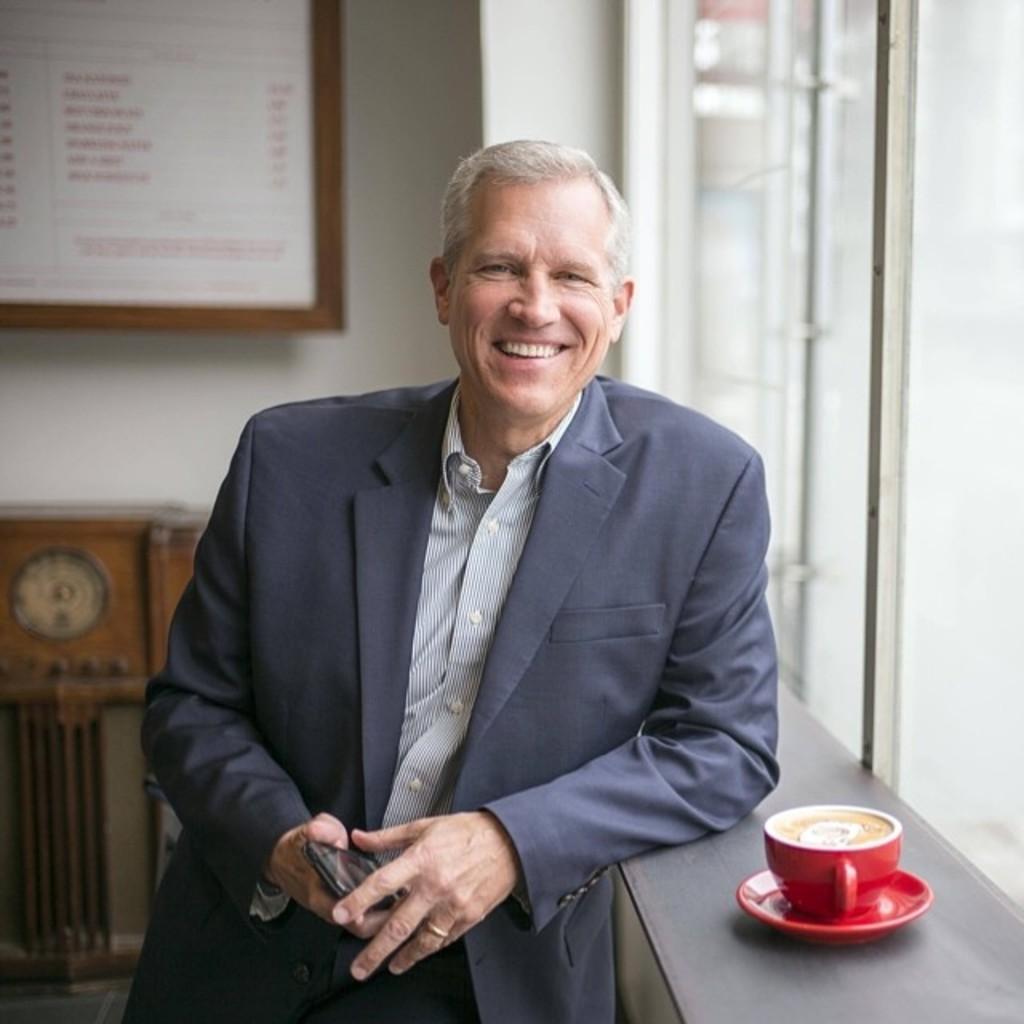Could you give a brief overview of what you see in this image? In the image in the center we can see one man standing and holding phone. And he is smiling,which we can see on his face. On the right side,there is a table,cup,saucer and coffee. In the background there is a wallboard,table,glass window and few other objects. 